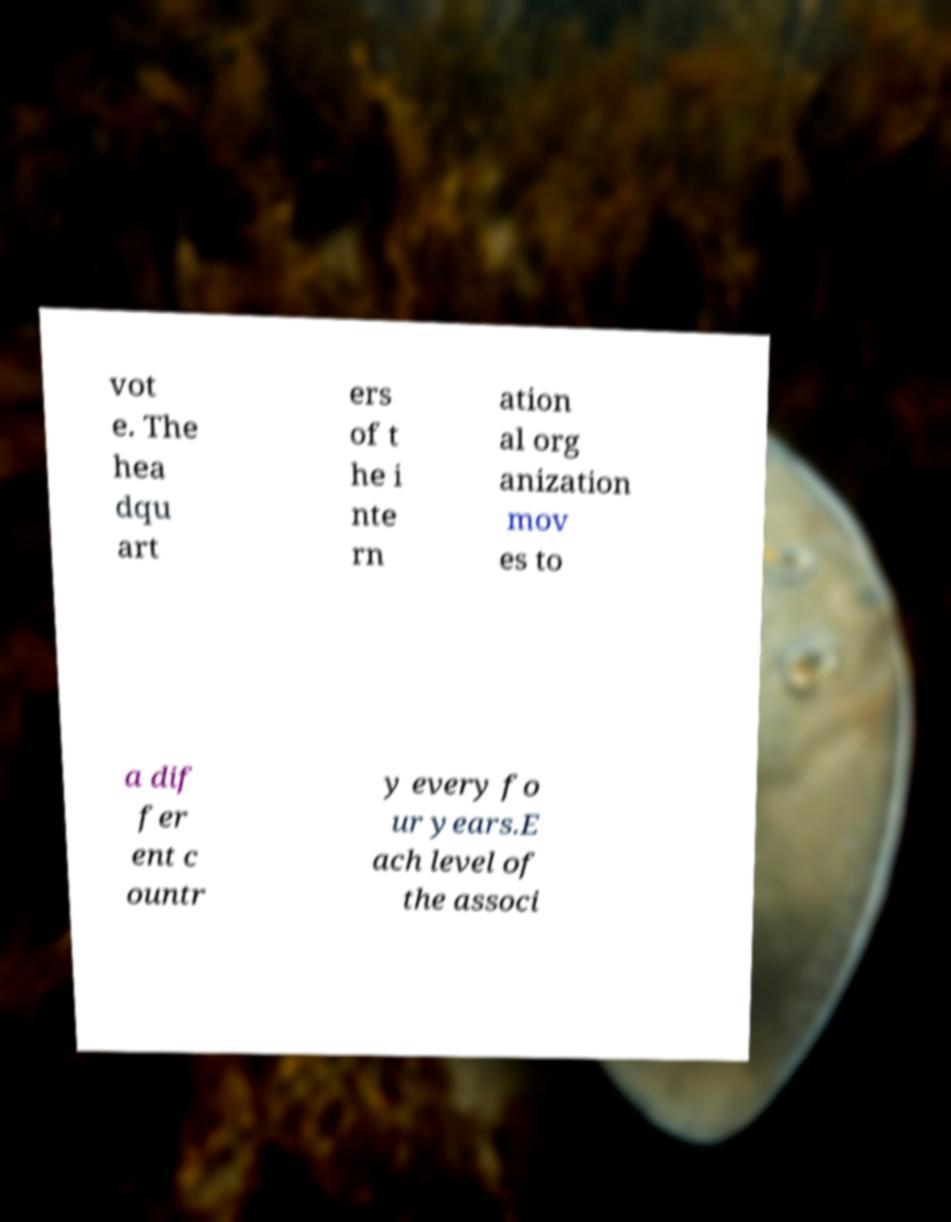For documentation purposes, I need the text within this image transcribed. Could you provide that? vot e. The hea dqu art ers of t he i nte rn ation al org anization mov es to a dif fer ent c ountr y every fo ur years.E ach level of the associ 